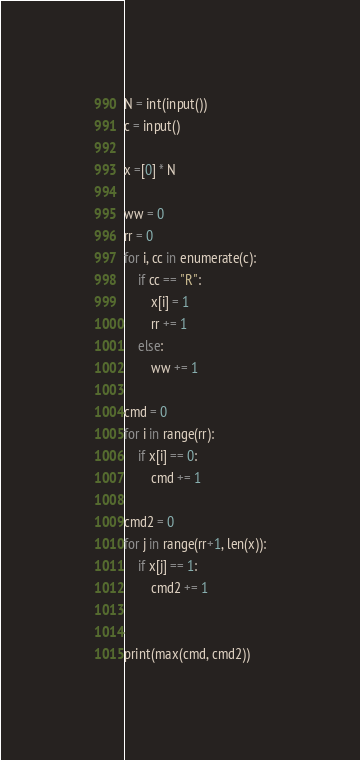<code> <loc_0><loc_0><loc_500><loc_500><_Python_>N = int(input())
c = input()

x =[0] * N

ww = 0
rr = 0
for i, cc in enumerate(c):
    if cc == "R":
        x[i] = 1
        rr += 1
    else:
        ww += 1

cmd = 0
for i in range(rr):
    if x[i] == 0:
        cmd += 1

cmd2 = 0
for j in range(rr+1, len(x)):
    if x[j] == 1:
        cmd2 += 1


print(max(cmd, cmd2))


</code> 